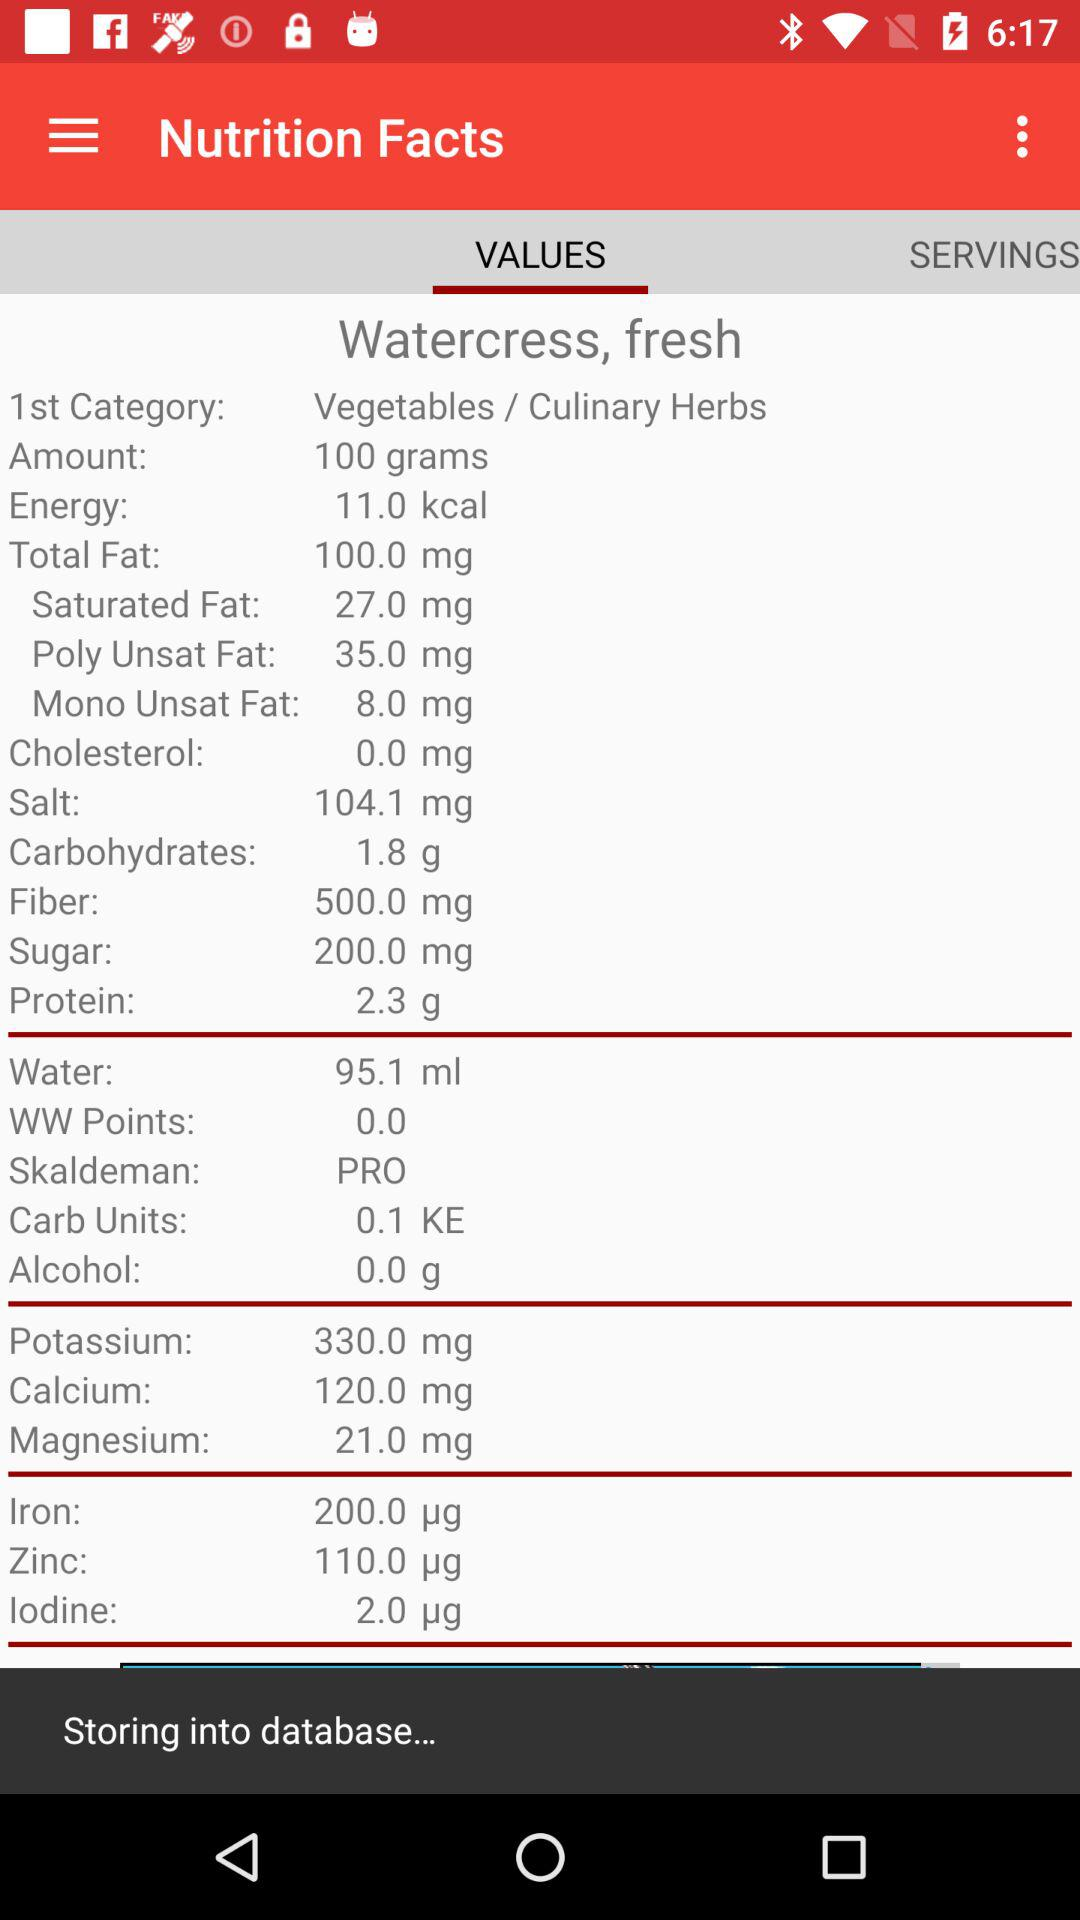Which component's composition is 2.3 g? The component whose composition is 2.3 g is protein. 